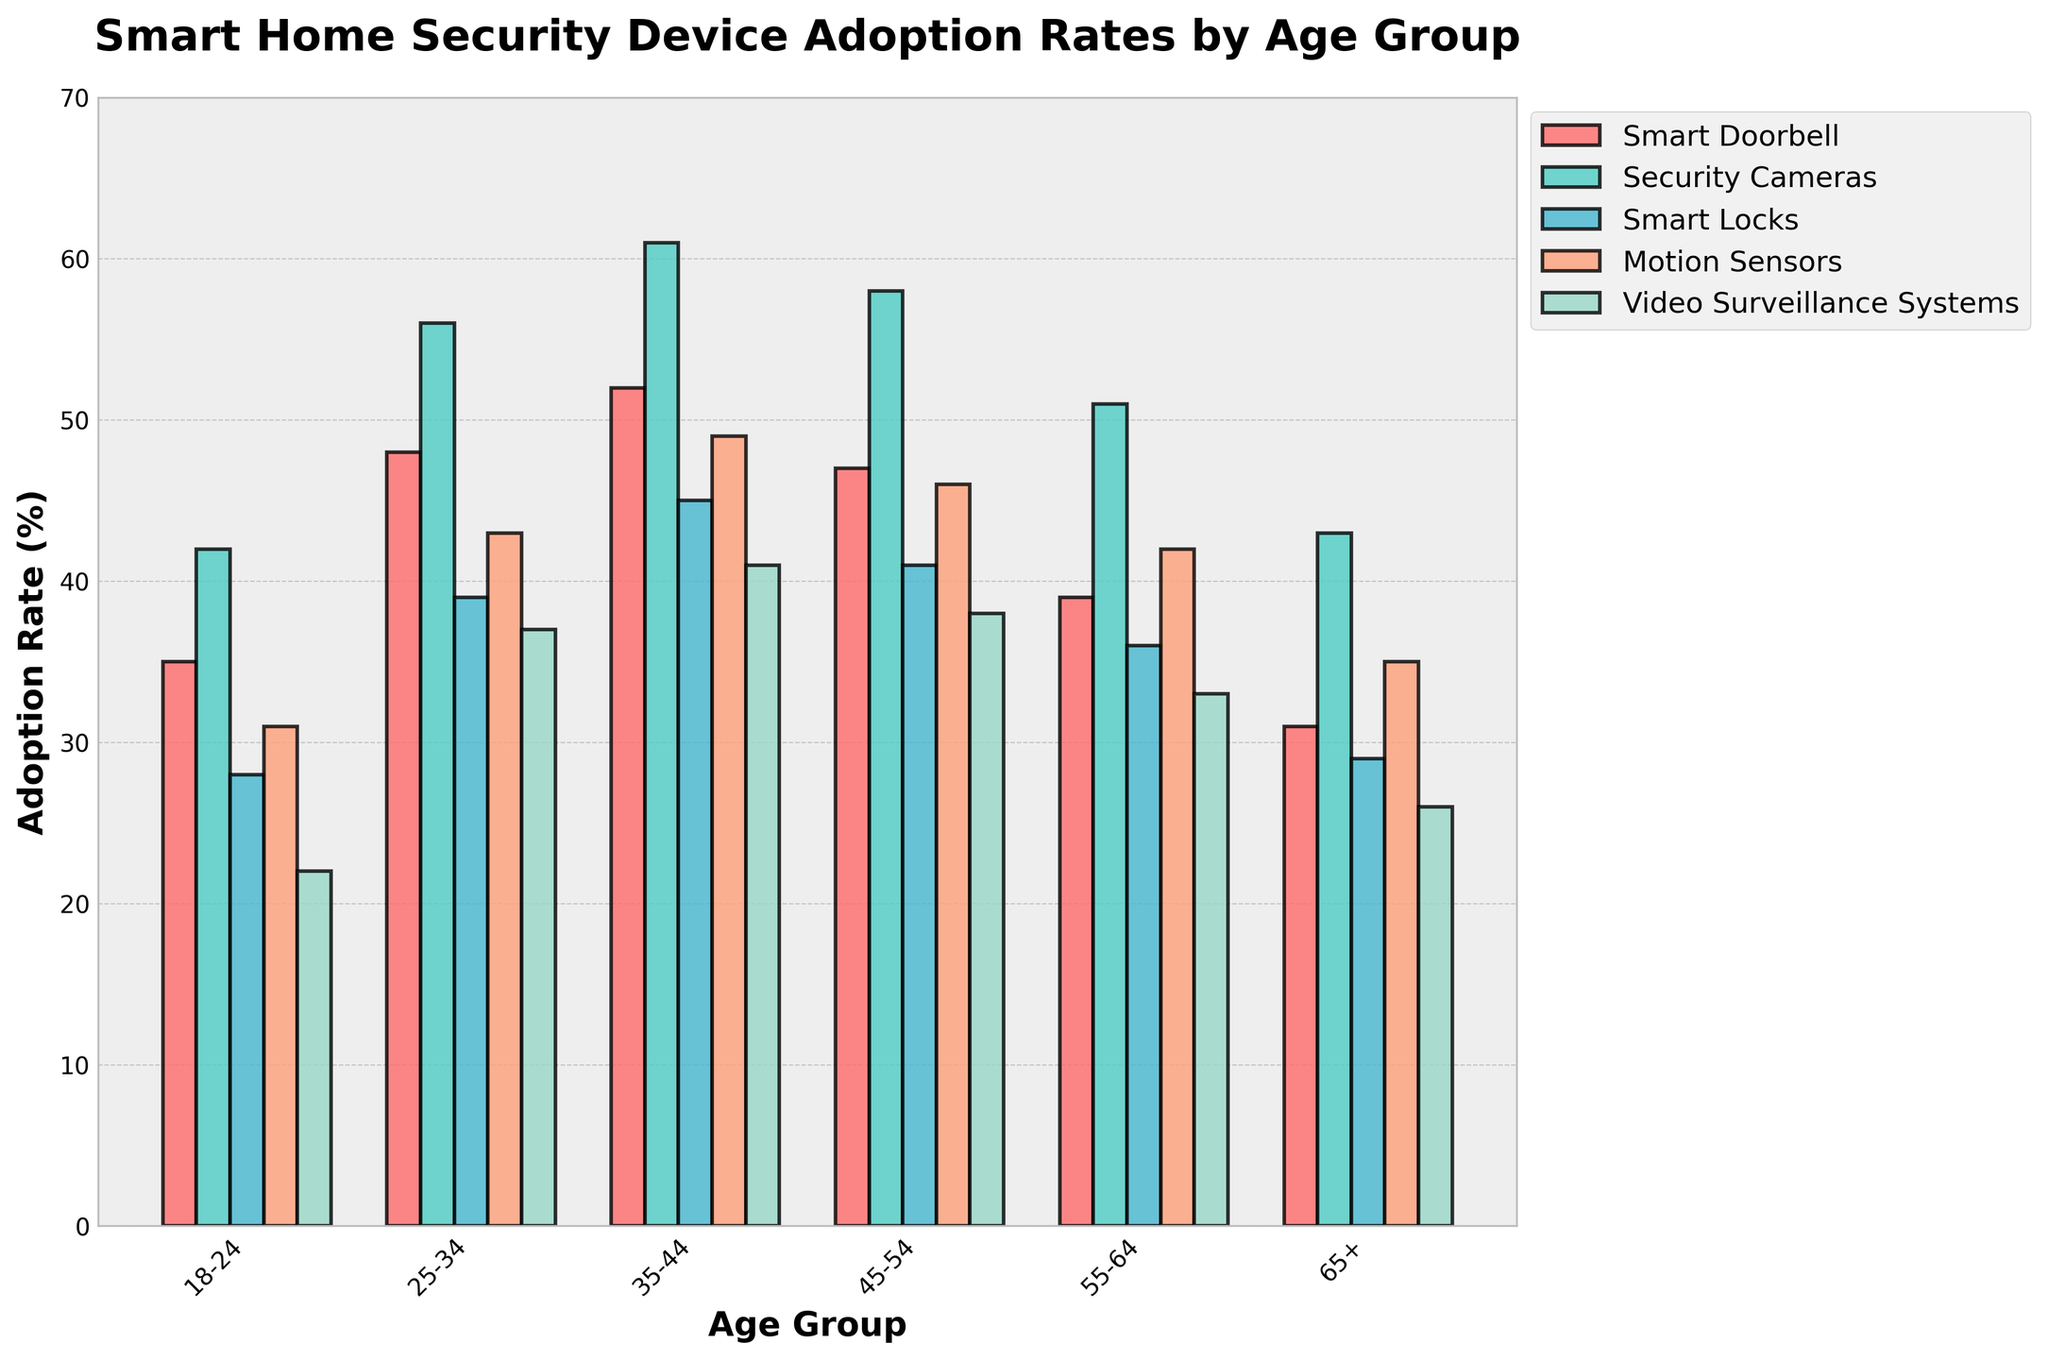What's the highest adoption rate of any smart home security device for the 25-34 age group? Look at the bar heights for the 25-34 age group. The bar representing Security Cameras has the highest value at 56%.
Answer: 56% Which age group has the lowest adoption rate of Video Surveillance Systems? Compare the heights of the bars representing Video Surveillance Systems across all age groups. The 65+ age group has the shortest bar at 26%.
Answer: 65+ By how much does the adoption rate of Smart Locks differ between the 35-44 and 55-64 age groups? Find the height of the bars for Smart Locks for both age groups: 45% (35-44) and 36% (55-64). The difference is 45% - 36% = 9%.
Answer: 9% What is the average adoption rate of Motion Sensors across all age groups? Sum the adoption rates of Motion Sensors for all age groups (31% + 43% + 49% + 46% + 42% + 35% = 246%) and divide by the number of age groups (6). The average is 246% / 6 = 41%.
Answer: 41% Which smart device has the most consistent adoption rate across all age groups (smallest range)? Determine the highest and lowest adoption rates for each device and calculate the ranges: Smart Doorbell (52% - 31% = 21%), Security Cameras (61% - 42% = 19%), Smart Locks (45% - 28% = 17%), Motion Sensors (49% - 31% = 18%), Video Surveillance Systems (41% - 22% = 19%). Smart Locks has the smallest range of 17%.
Answer: Smart Locks What is the total adoption rate for Smart Doorbells and Security Cameras in the 45-54 age group? Sum the adoption rates of Smart Doorbells (47%) and Security Cameras (58%) for the 45-54 age group: 47% + 58% = 105%.
Answer: 105% Is the adoption rate of Security Cameras for the 18-24 age group higher than that of Smart Locks for the 25-34 age group? Compare the heights of the bars: Security Cameras (42%) for 18-24 and Smart Locks (39%) for 25-34. 42% is greater than 39%.
Answer: Yes What is the ratio of the adoption rate of Smart Locks to Motion Sensors within the 55-64 age group? Find the adoption rates for Smart Locks (36%) and Motion Sensors (42%) in the 55-64 group. The ratio is 36% / 42% = 0.857.
Answer: 0.857 What is the sum of adoption rates for all devices in the 65+ age group? Sum the adoption rates for all devices: Smart Doorbell (31%), Security Cameras (43%), Smart Locks (29%), Motion Sensors (35%), Video Surveillance Systems (26%). The total is 31% + 43% + 29% + 35% + 26% = 164%.
Answer: 164% 